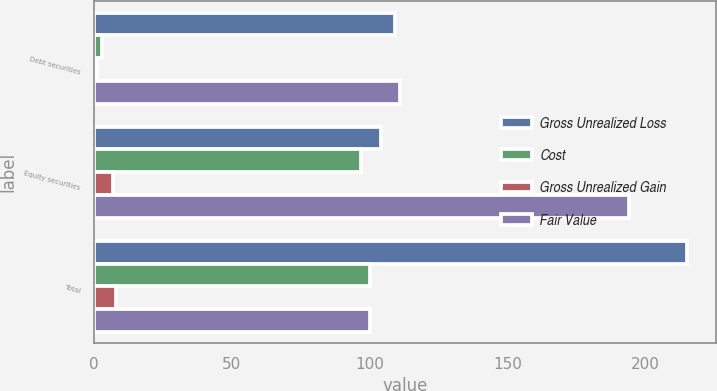Convert chart to OTSL. <chart><loc_0><loc_0><loc_500><loc_500><stacked_bar_chart><ecel><fcel>Debt securities<fcel>Equity securities<fcel>Total<nl><fcel>Gross Unrealized Loss<fcel>109<fcel>104<fcel>215<nl><fcel>Cost<fcel>3<fcel>97<fcel>100<nl><fcel>Gross Unrealized Gain<fcel>1<fcel>7<fcel>8<nl><fcel>Fair Value<fcel>111<fcel>194<fcel>100<nl></chart> 